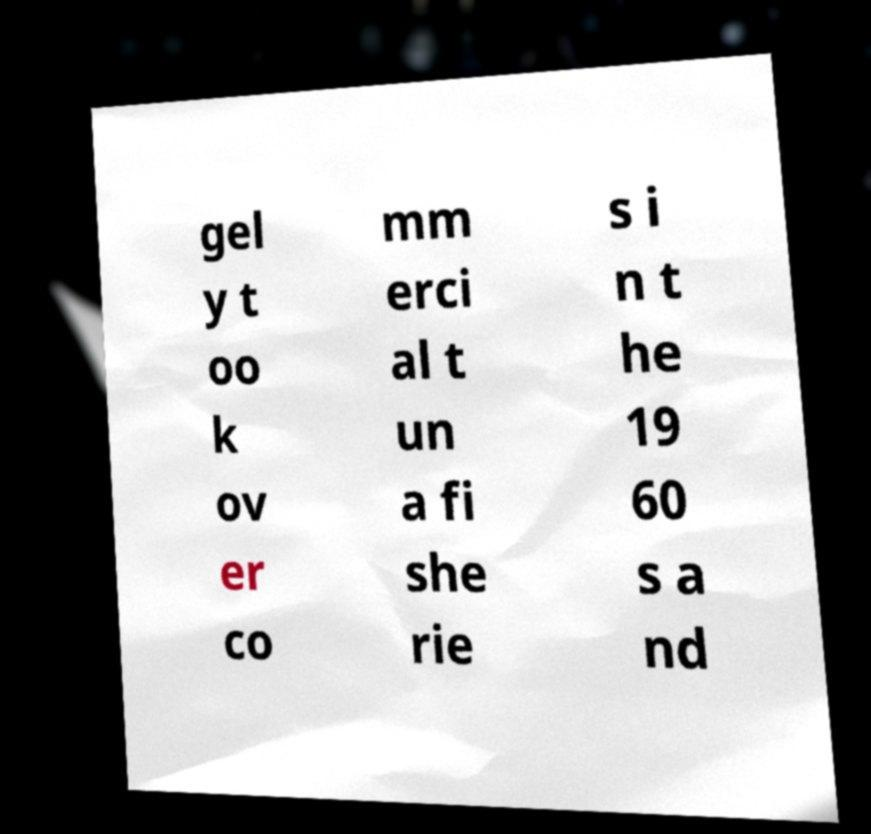Could you extract and type out the text from this image? gel y t oo k ov er co mm erci al t un a fi she rie s i n t he 19 60 s a nd 